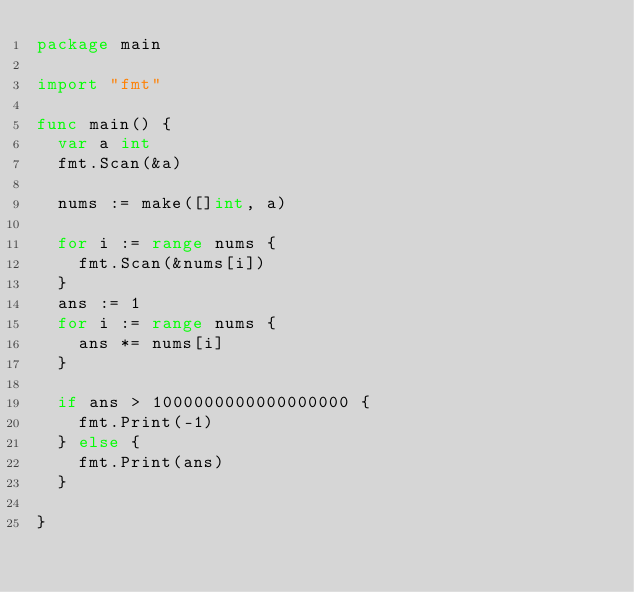<code> <loc_0><loc_0><loc_500><loc_500><_Go_>package main

import "fmt"

func main() {
	var a int
	fmt.Scan(&a)

	nums := make([]int, a)

	for i := range nums {
		fmt.Scan(&nums[i])
	}
	ans := 1
	for i := range nums {
		ans *= nums[i]
	}

	if ans > 1000000000000000000 {
		fmt.Print(-1)
	} else {
		fmt.Print(ans)
	}

}
</code> 